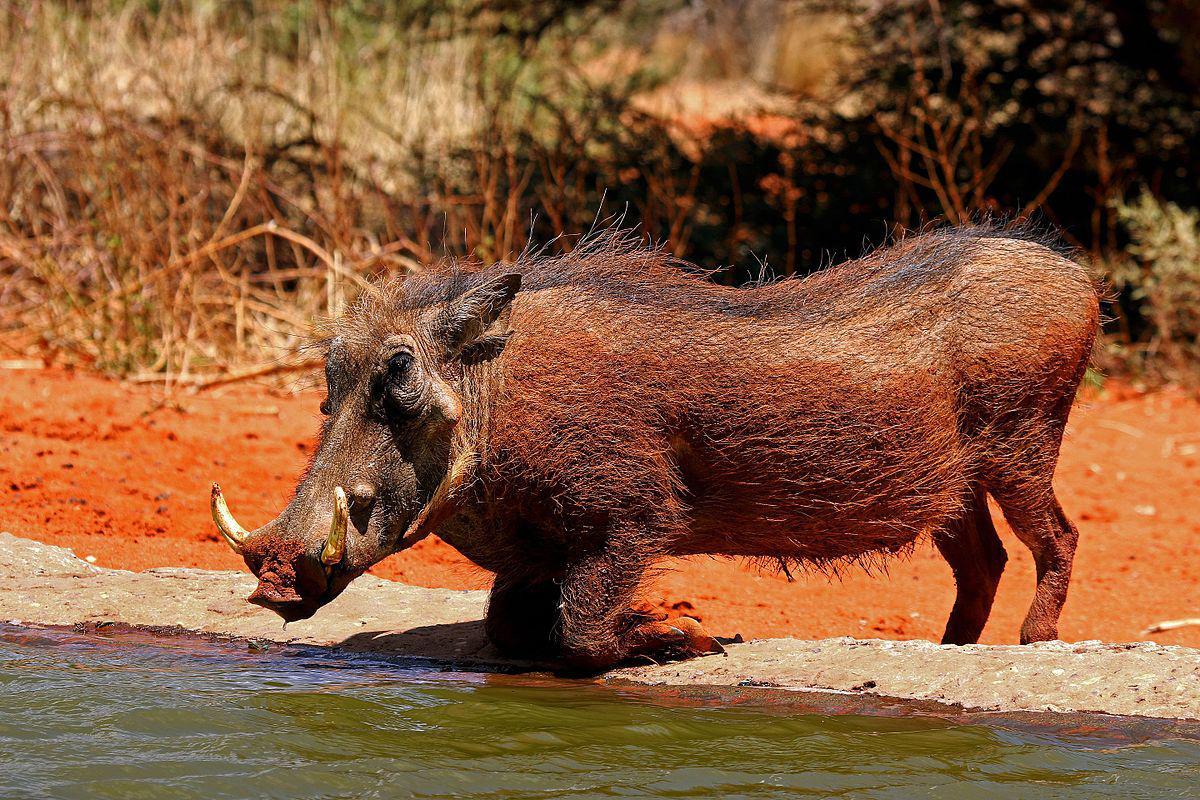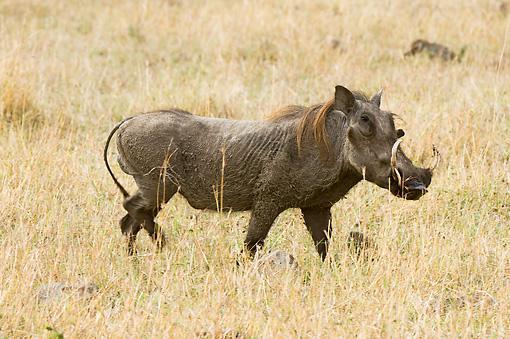The first image is the image on the left, the second image is the image on the right. Given the left and right images, does the statement "There are two hogs facing left." hold true? Answer yes or no. No. 